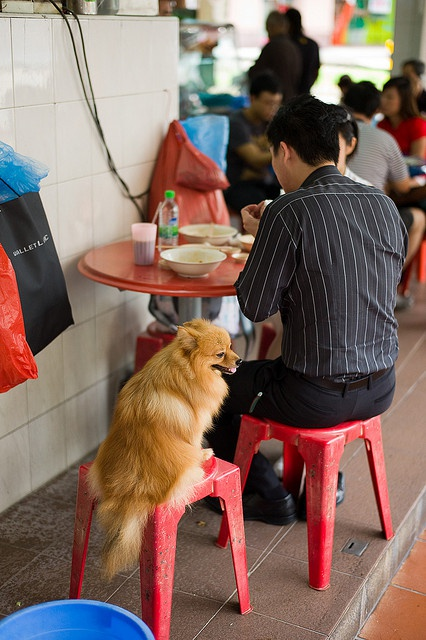Describe the objects in this image and their specific colors. I can see people in black, gray, and darkgray tones, dog in black, olive, tan, and maroon tones, dining table in black, brown, and tan tones, people in black, maroon, and gray tones, and people in black, darkgray, and gray tones in this image. 